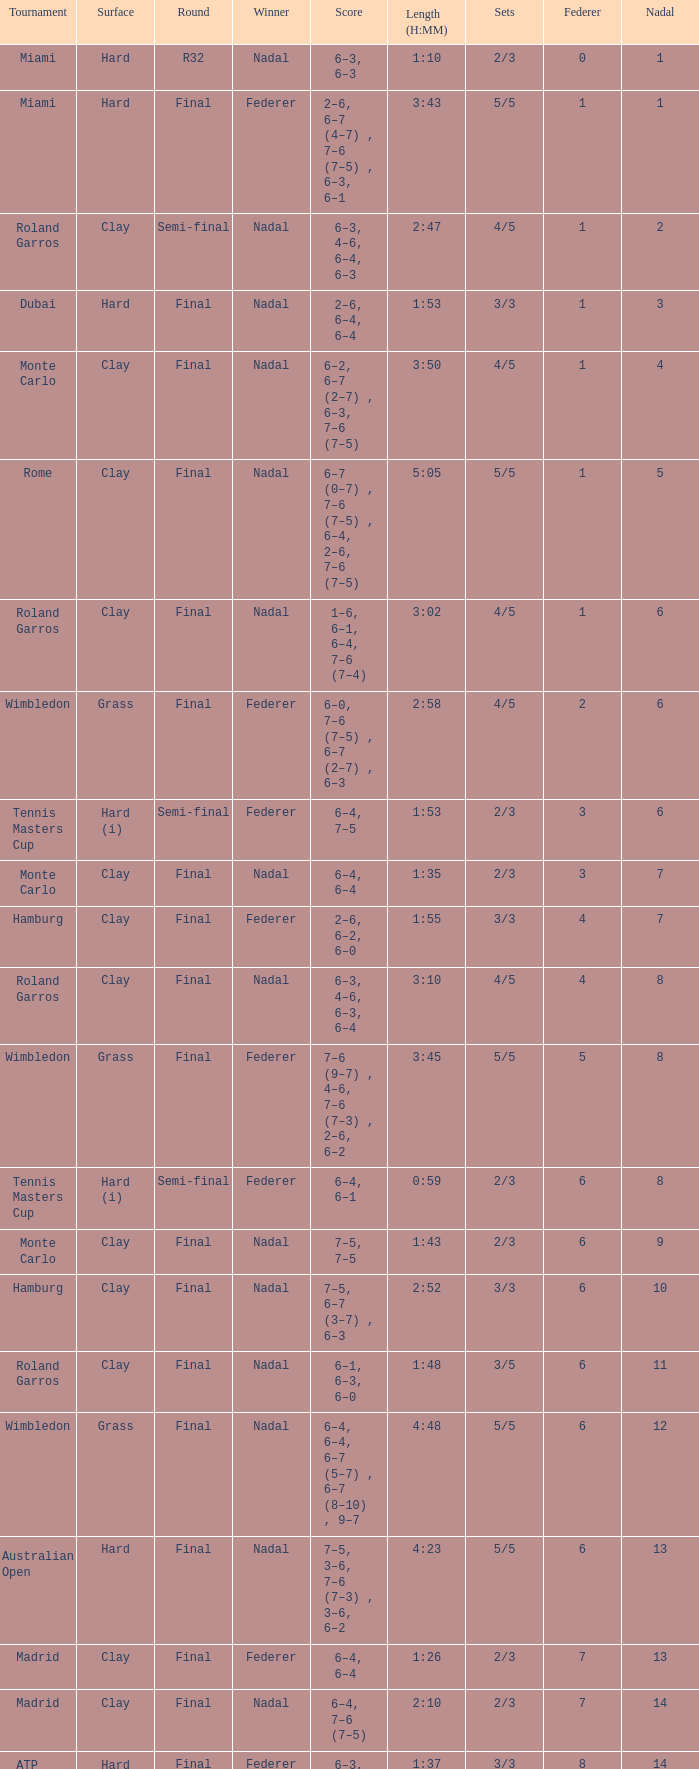What was the nadal in Miami in the final round? 1.0. 